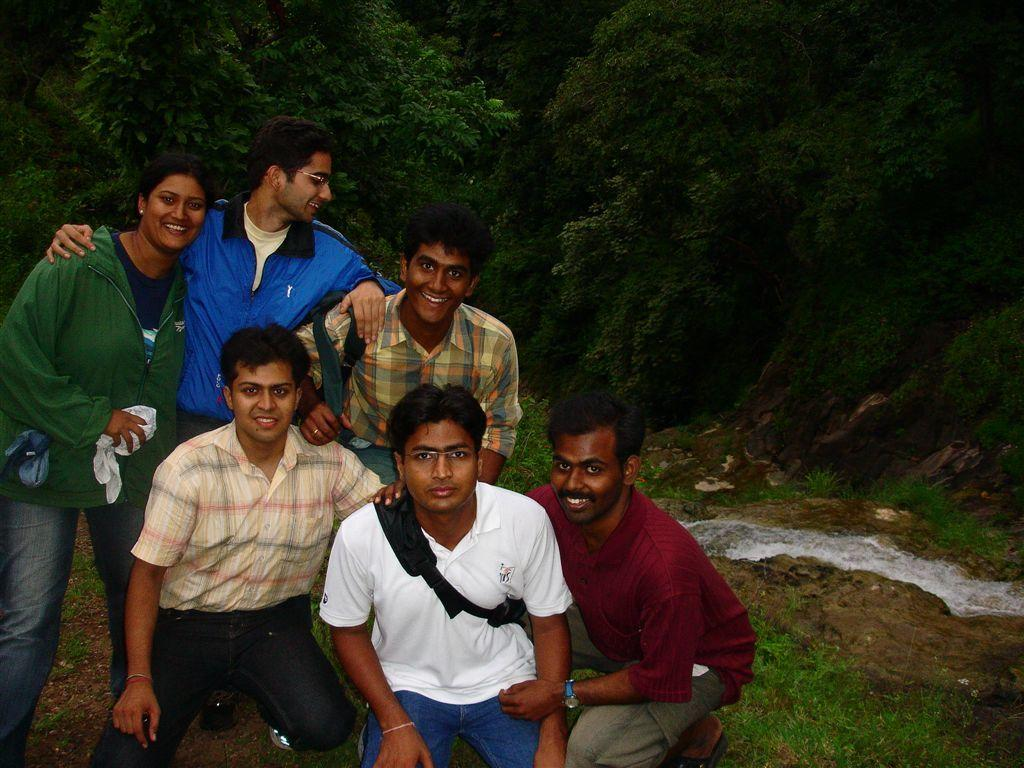What is the main subject of the image? The main subject of the image is a group of people. How can you describe the appearance of the people in the image? The people are wearing different color dresses. What can be seen in the background of the image? There are trees visible in the background of the image. What language are the people speaking in the image? The image does not provide any information about the language being spoken by the people. Can you see any steam coming from the trees in the background? There is no steam visible in the image, and the trees are not producing steam. 